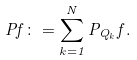Convert formula to latex. <formula><loc_0><loc_0><loc_500><loc_500>P f \colon = \sum _ { k = 1 } ^ { N } P _ { Q _ { k } } f .</formula> 